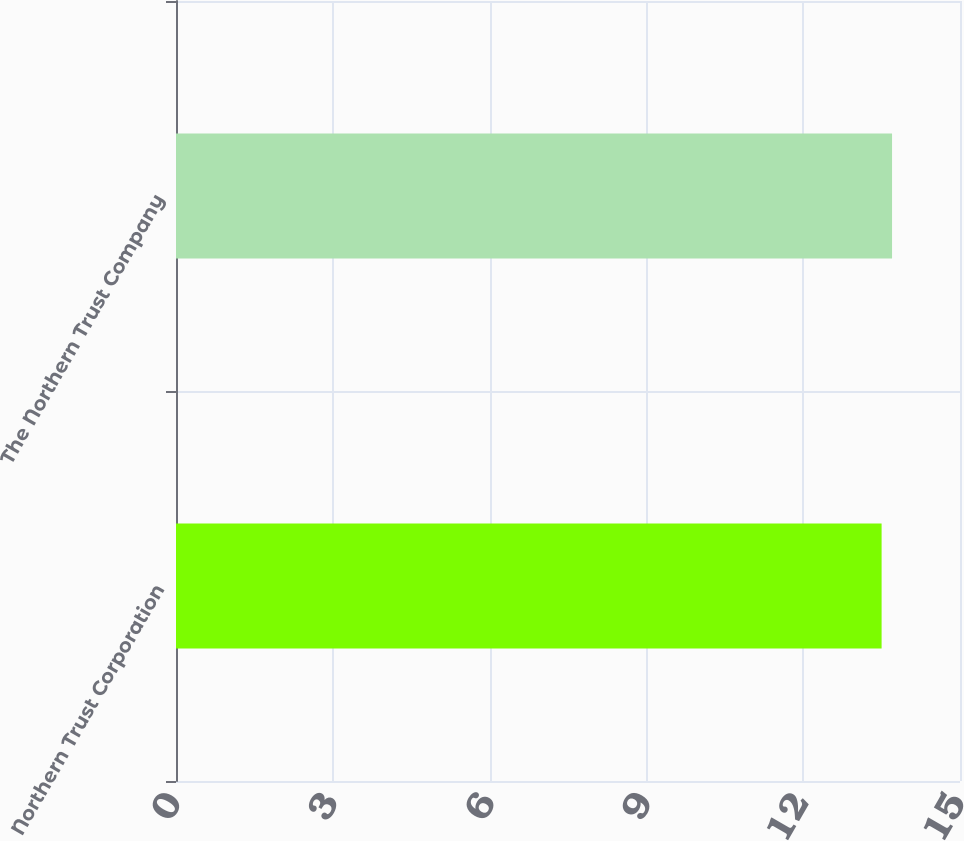Convert chart to OTSL. <chart><loc_0><loc_0><loc_500><loc_500><bar_chart><fcel>Northern Trust Corporation<fcel>The Northern Trust Company<nl><fcel>13.5<fcel>13.7<nl></chart> 